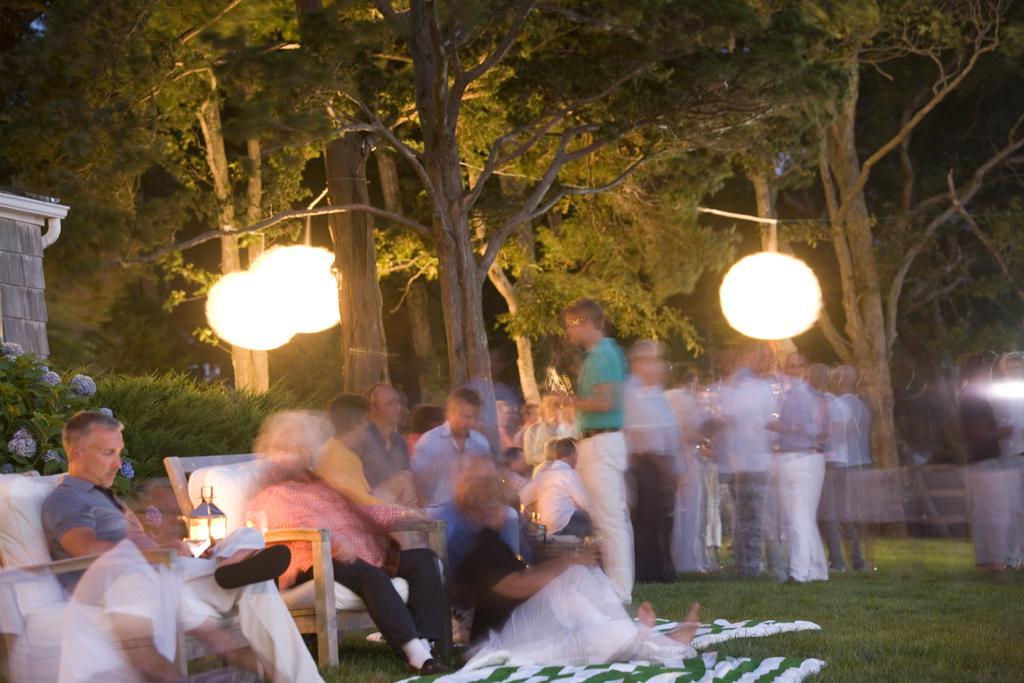Describe this image in one or two sentences. At the bottom of the image there are few people sitting on the ground and few are sitting on the chairs. In the background there are trees with lamps hanging to it. On the left side of the image there are plants and also there is a wall. 